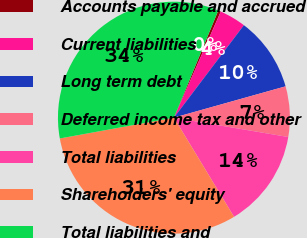Convert chart. <chart><loc_0><loc_0><loc_500><loc_500><pie_chart><fcel>Accounts payable and accrued<fcel>Current liabilities<fcel>Long term debt<fcel>Deferred income tax and other<fcel>Total liabilities<fcel>Shareholders' equity<fcel>Total liabilities and<nl><fcel>0.37%<fcel>3.69%<fcel>10.34%<fcel>7.02%<fcel>13.66%<fcel>30.8%<fcel>34.12%<nl></chart> 